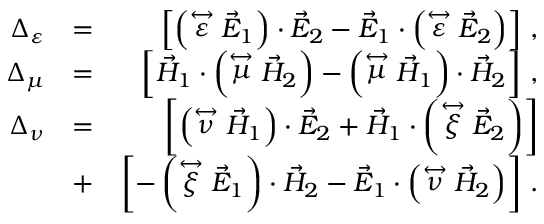Convert formula to latex. <formula><loc_0><loc_0><loc_500><loc_500>\begin{array} { r l r } { \Delta _ { \varepsilon } } & { = } & { \left [ \left ( \stackrel { \leftrightarrow } { \varepsilon } \vec { E } _ { 1 } \right ) \cdot \vec { E } _ { 2 } - \vec { E } _ { 1 } \cdot \left ( \stackrel { \leftrightarrow } { \varepsilon } \vec { E } _ { 2 } \right ) \right ] \, , } \\ { \Delta _ { \mu } } & { = } & { \left [ \vec { H } _ { 1 } \cdot \left ( \stackrel { \leftrightarrow } { \mu } \vec { H } _ { 2 } \right ) - \left ( \stackrel { \leftrightarrow } { \mu } \vec { H } _ { 1 } \right ) \cdot \vec { H } _ { 2 } \right ] \, , } \\ { \Delta _ { \nu } } & { = } & { \left [ \left ( \stackrel { \leftrightarrow } { \nu } \vec { H } _ { 1 } \right ) \cdot \vec { E } _ { 2 } + \vec { H } _ { 1 } \cdot \left ( \stackrel { \leftrightarrow } { \xi } \vec { E } _ { 2 } \right ) \right ] } \\ & { + } & { \left [ - \left ( \stackrel { \leftrightarrow } { \xi } \vec { E } _ { 1 } \right ) \cdot \vec { H } _ { 2 } - \vec { E } _ { 1 } \cdot \left ( \stackrel { \leftrightarrow } { \nu } \vec { H } _ { 2 } \right ) \right ] \, . } \end{array}</formula> 